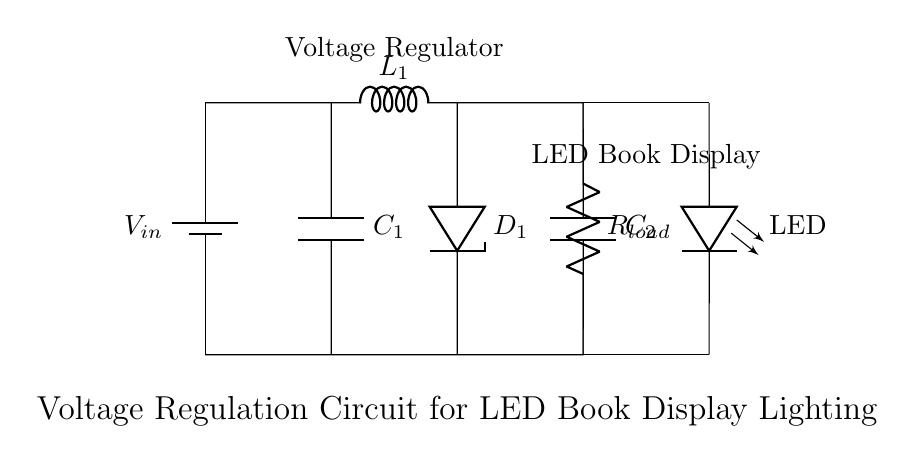What type of voltage regulator is used in this circuit? The circuit contains a Zener diode, which is commonly used for voltage regulation. The Zener diode provides a stable reference voltage to maintain the output voltage across the LED.
Answer: Zener diode What is the purpose of capacitor C1 in this circuit? Capacitor C1 is used for filtering. It smooths out voltage fluctuations from the power supply and helps in stabilizing the output voltage to the LEDs.
Answer: Filtering What components are needed to protect the LED from overvoltage? The Zener diode D1 acts as the primary protection component, clamping excess voltage to prevent overvoltage conditions that could damage the LED.
Answer: Zener diode What is the effect of capacitor C2 in this circuit? Capacitor C2 also functions as a filter, but additionally, it helps with transient response by providing charge during sudden load changes, thus maintaining a stable voltage.
Answer: Stabilization Which connection maintains the flow of current through the LED? The connections between nodes (6,4) and (8,4) for the upper side, as well as (6,0) and (8,0) for the lower side, directly link the LED to the regulated voltage, allowing current to flow through it.
Answer: Connection to LED What is the significance of the inductor L1 in this circuit? The inductor L1 helps in reducing ripple voltage by storing energy when current increases and releasing it when current decreases, contributing to a smoother voltage output.
Answer: Ripple reduction What voltage does the LED require in this configuration? The LED operates typically at a forward voltage of around 2 to 3 volts; however, the exact value depends on the LED type, which is not specified in the circuit.
Answer: Approximately 2 to 3 volts 